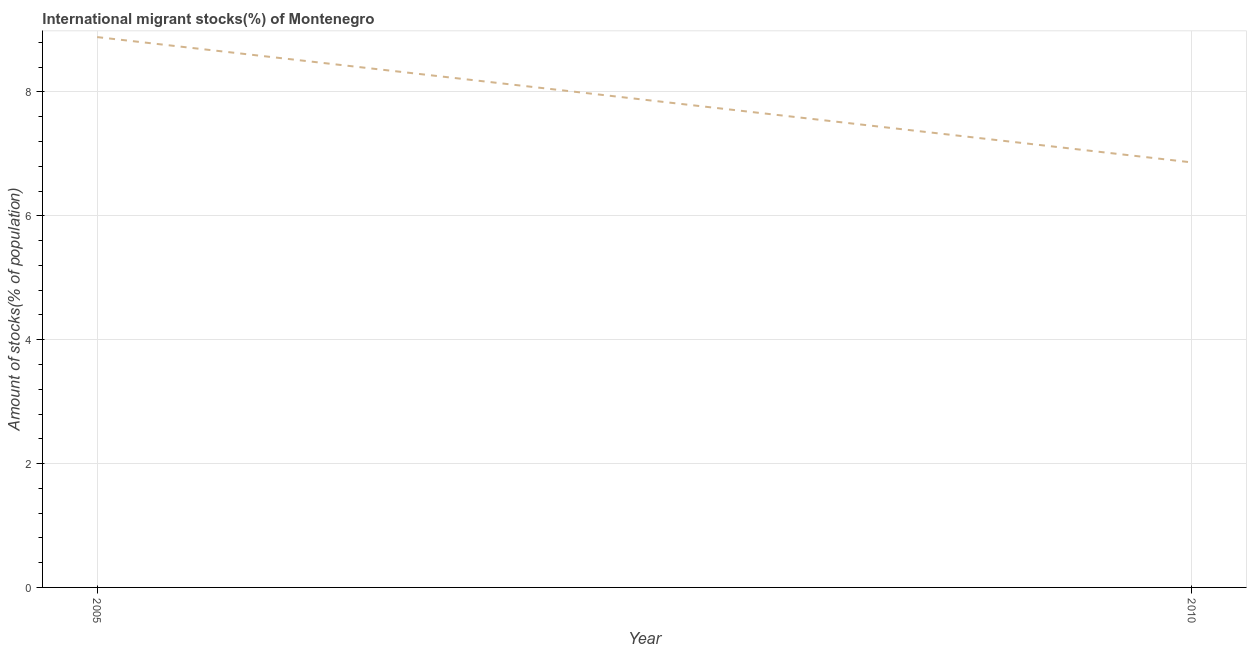What is the number of international migrant stocks in 2005?
Ensure brevity in your answer.  8.89. Across all years, what is the maximum number of international migrant stocks?
Provide a succinct answer. 8.89. Across all years, what is the minimum number of international migrant stocks?
Offer a terse response. 6.86. What is the sum of the number of international migrant stocks?
Provide a succinct answer. 15.75. What is the difference between the number of international migrant stocks in 2005 and 2010?
Give a very brief answer. 2.02. What is the average number of international migrant stocks per year?
Keep it short and to the point. 7.87. What is the median number of international migrant stocks?
Make the answer very short. 7.87. What is the ratio of the number of international migrant stocks in 2005 to that in 2010?
Give a very brief answer. 1.29. Does the number of international migrant stocks monotonically increase over the years?
Your answer should be very brief. No. How many years are there in the graph?
Your response must be concise. 2. What is the difference between two consecutive major ticks on the Y-axis?
Make the answer very short. 2. Does the graph contain any zero values?
Give a very brief answer. No. Does the graph contain grids?
Your response must be concise. Yes. What is the title of the graph?
Offer a very short reply. International migrant stocks(%) of Montenegro. What is the label or title of the Y-axis?
Make the answer very short. Amount of stocks(% of population). What is the Amount of stocks(% of population) of 2005?
Keep it short and to the point. 8.89. What is the Amount of stocks(% of population) of 2010?
Your response must be concise. 6.86. What is the difference between the Amount of stocks(% of population) in 2005 and 2010?
Your response must be concise. 2.02. What is the ratio of the Amount of stocks(% of population) in 2005 to that in 2010?
Ensure brevity in your answer.  1.29. 